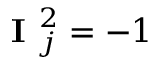<formula> <loc_0><loc_0><loc_500><loc_500>I _ { j } ^ { 2 } = - 1</formula> 